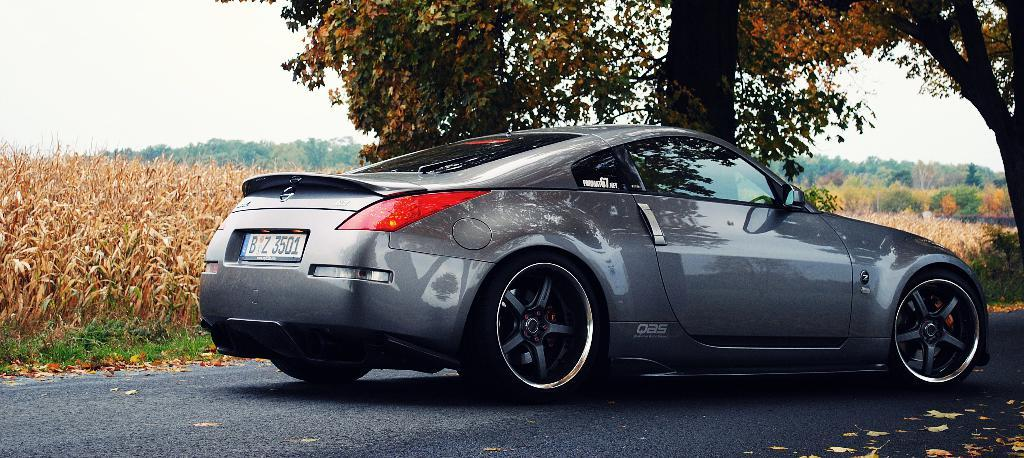What is the main subject of the image? The main subject of the image is a car. Where is the car located in the image? The car is on the road in the image. What can be seen in the background of the image? There are trees and plants in the background of the image. What type of thumb can be seen in the image? There is no thumb present in the image. 